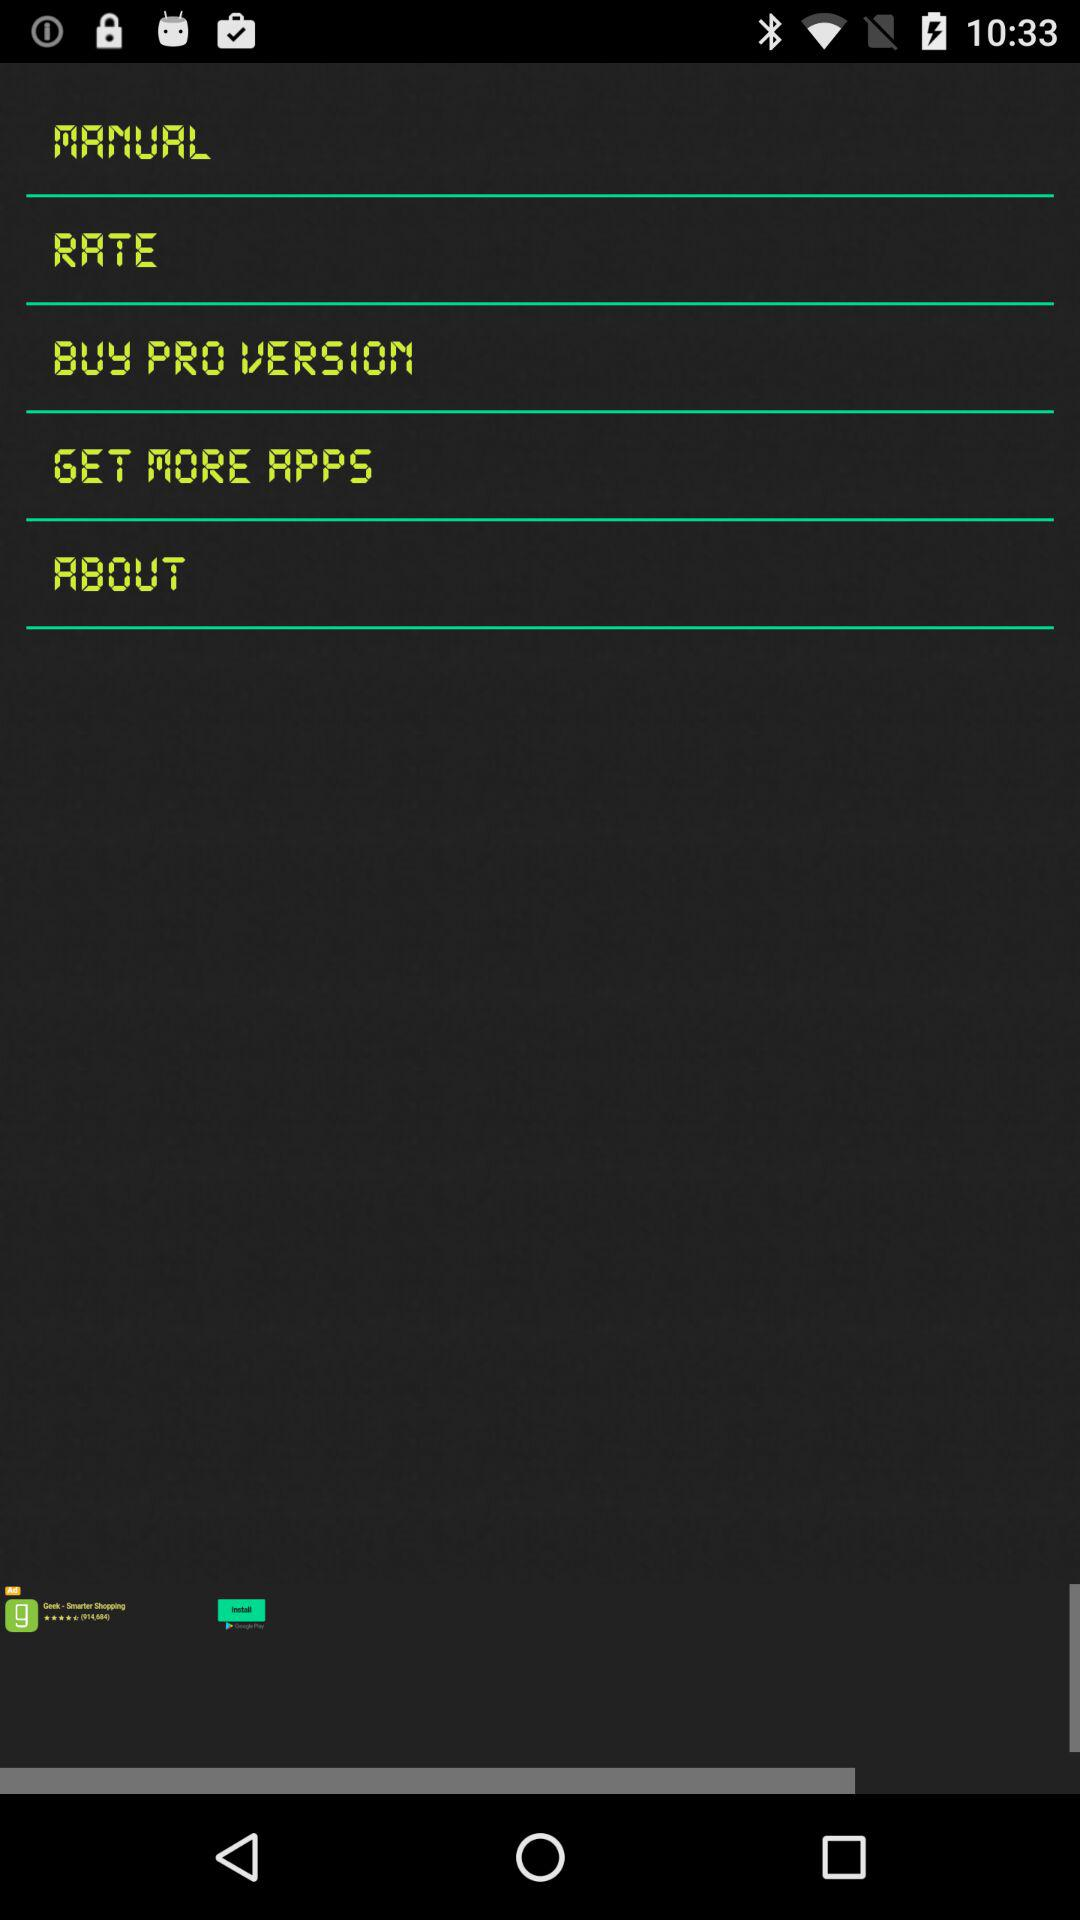What are the different functions that can be performed through the agent menu? The different functions that can be performed through the agent menu are diagnostics, location, torch, camera, compass, audio, sensors, spectrum and report. 